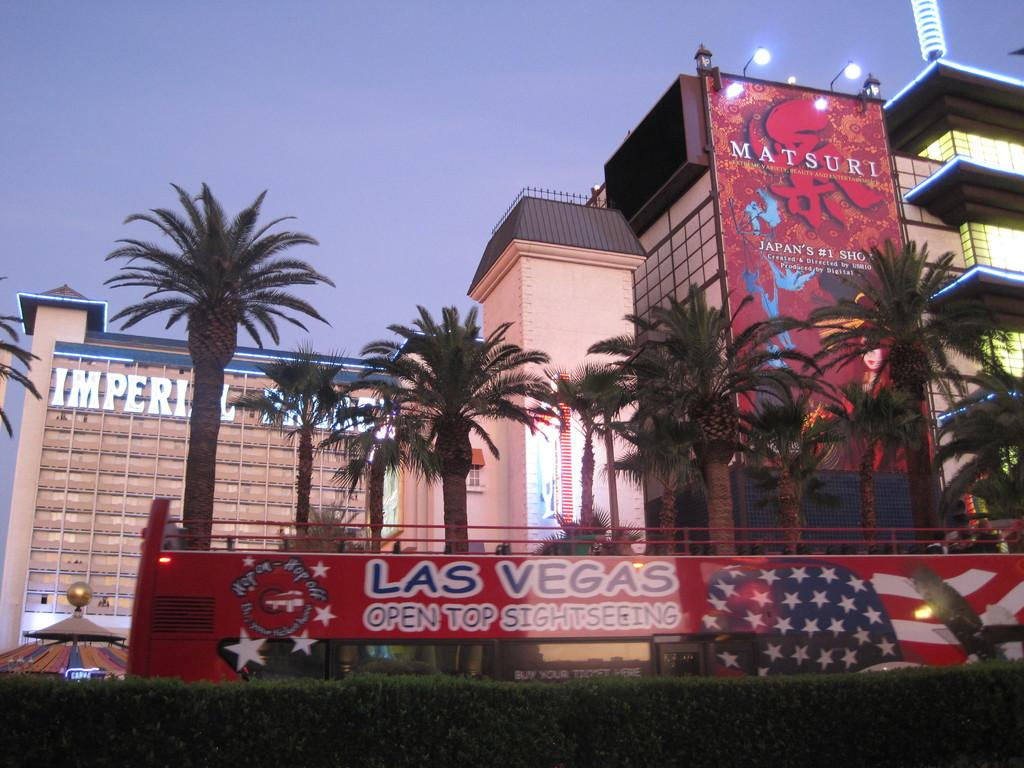What type of structures can be seen in the image? There are buildings in the image. What natural elements are present in the image? There are trees in the image. What objects are visible in the image? There are boards and lights in the image. What can be seen in the background of the image? The sky is visible in the background of the image. What type of spark can be seen in the image? There is no spark present in the image. 